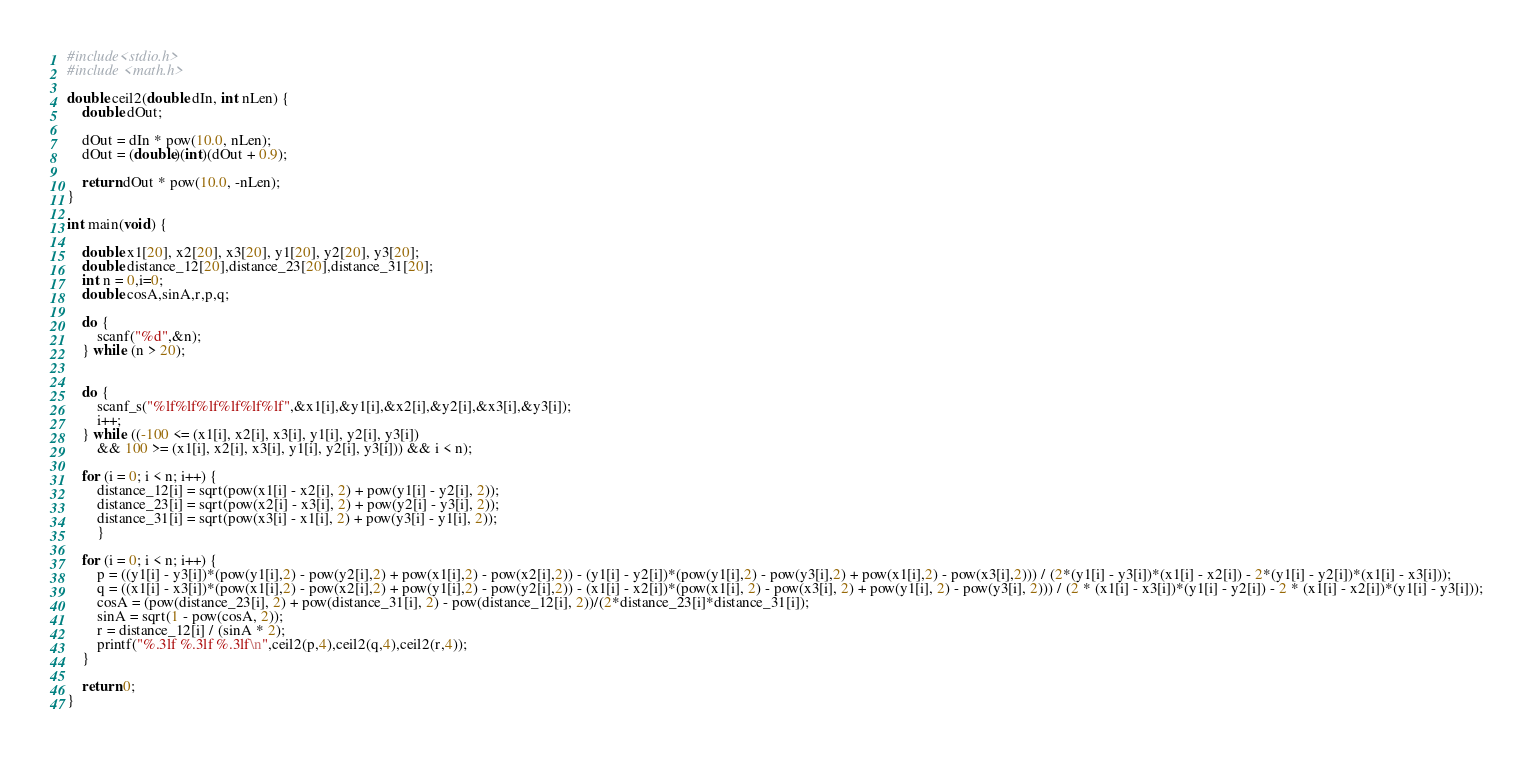Convert code to text. <code><loc_0><loc_0><loc_500><loc_500><_C_>#include<stdio.h>
#include <math.h>

double ceil2(double dIn, int nLen) {
	double dOut;

	dOut = dIn * pow(10.0, nLen);
	dOut = (double)(int)(dOut + 0.9);

	return dOut * pow(10.0, -nLen);
}

int main(void) {

	double x1[20], x2[20], x3[20], y1[20], y2[20], y3[20];
	double distance_12[20],distance_23[20],distance_31[20];
	int n = 0,i=0;
	double cosA,sinA,r,p,q;

	do {
		scanf("%d",&n);
	} while (n > 20);
	

	do {
		scanf_s("%lf%lf%lf%lf%lf%lf",&x1[i],&y1[i],&x2[i],&y2[i],&x3[i],&y3[i]);
		i++;
	} while ((-100 <= (x1[i], x2[i], x3[i], y1[i], y2[i], y3[i]) 
		&& 100 >= (x1[i], x2[i], x3[i], y1[i], y2[i], y3[i])) && i < n);
	
	for (i = 0; i < n; i++) {
		distance_12[i] = sqrt(pow(x1[i] - x2[i], 2) + pow(y1[i] - y2[i], 2));
		distance_23[i] = sqrt(pow(x2[i] - x3[i], 2) + pow(y2[i] - y3[i], 2));
		distance_31[i] = sqrt(pow(x3[i] - x1[i], 2) + pow(y3[i] - y1[i], 2));
		}

	for (i = 0; i < n; i++) {
		p = ((y1[i] - y3[i])*(pow(y1[i],2) - pow(y2[i],2) + pow(x1[i],2) - pow(x2[i],2)) - (y1[i] - y2[i])*(pow(y1[i],2) - pow(y3[i],2) + pow(x1[i],2) - pow(x3[i],2))) / (2*(y1[i] - y3[i])*(x1[i] - x2[i]) - 2*(y1[i] - y2[i])*(x1[i] - x3[i]));
		q = ((x1[i] - x3[i])*(pow(x1[i],2) - pow(x2[i],2) + pow(y1[i],2) - pow(y2[i],2)) - (x1[i] - x2[i])*(pow(x1[i], 2) - pow(x3[i], 2) + pow(y1[i], 2) - pow(y3[i], 2))) / (2 * (x1[i] - x3[i])*(y1[i] - y2[i]) - 2 * (x1[i] - x2[i])*(y1[i] - y3[i]));
		cosA = (pow(distance_23[i], 2) + pow(distance_31[i], 2) - pow(distance_12[i], 2))/(2*distance_23[i]*distance_31[i]);
		sinA = sqrt(1 - pow(cosA, 2));
		r = distance_12[i] / (sinA * 2);
		printf("%.3lf %.3lf %.3lf\n",ceil2(p,4),ceil2(q,4),ceil2(r,4));
	}

	return 0;
}</code> 